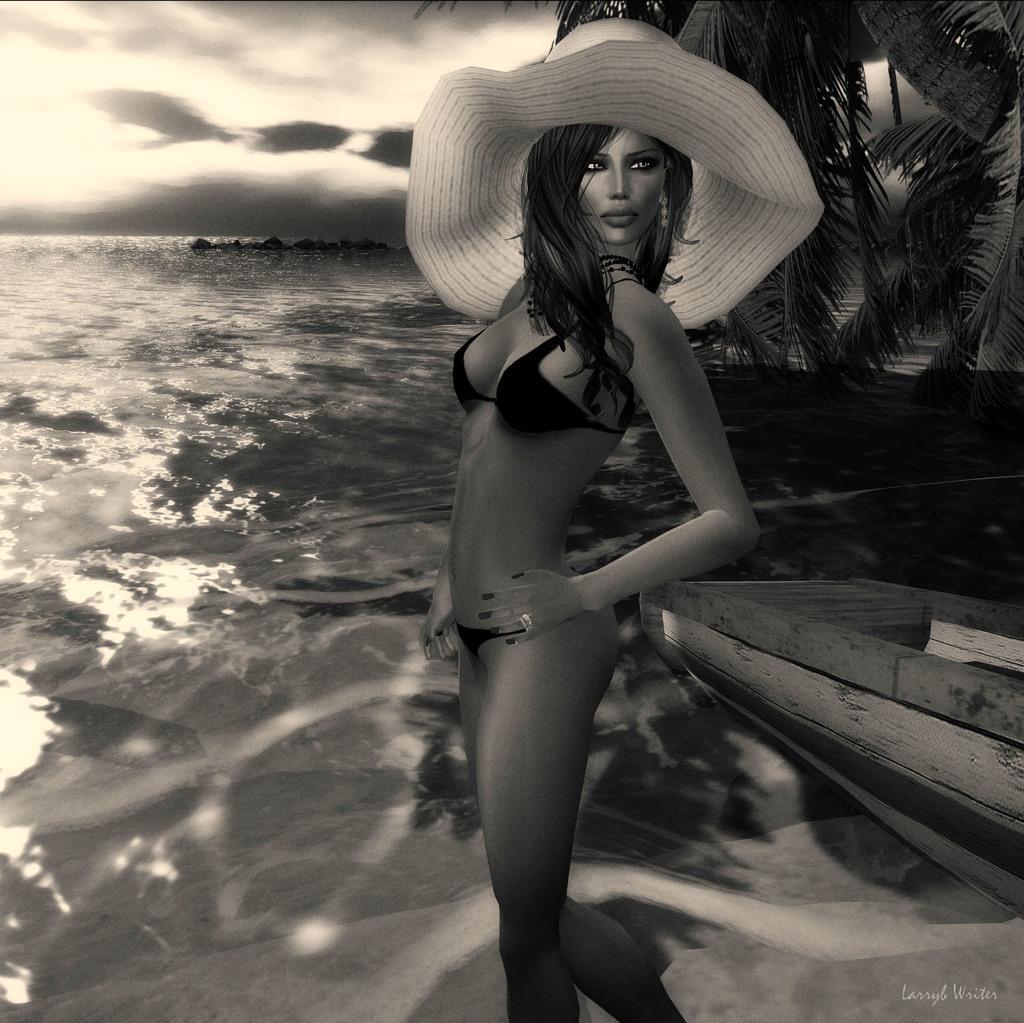In one or two sentences, can you explain what this image depicts? Here in this picture we can see an animated woman wearing hat on her and beside her we can see a boat and we can see water present all over there and we can see trees and clouds in the sky. 